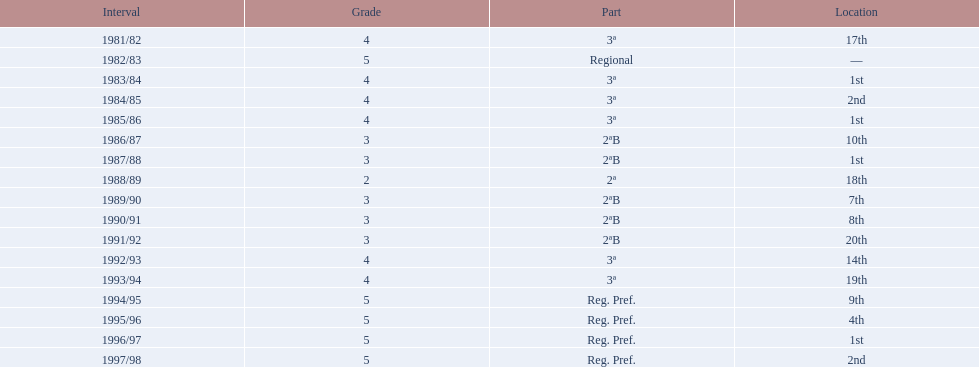What were the number of times second place was earned? 2. 